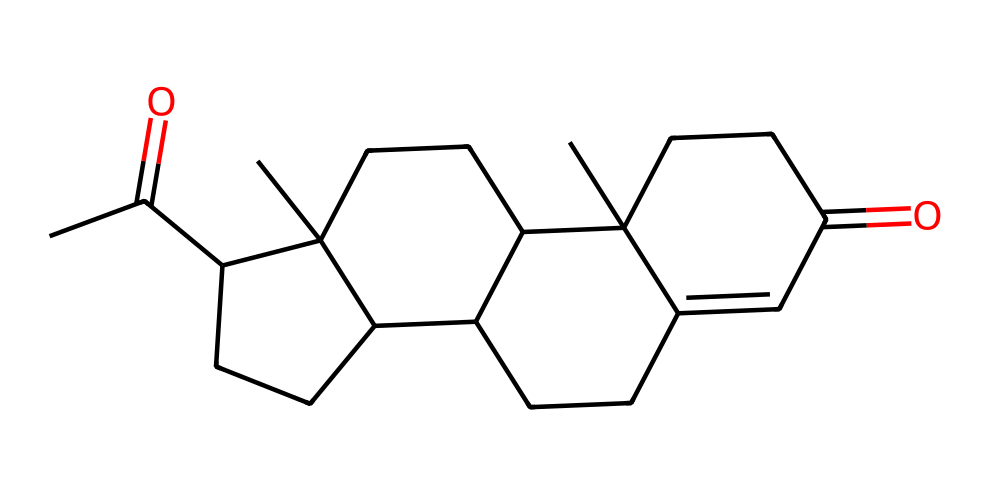What is the molecular formula of the compound represented by this SMILES? To determine the molecular formula from the SMILES representation, we count the atoms of each element present in the structure. The given SMILES contains 21 carbon (C) atoms, 30 hydrogen (H) atoms, and 2 oxygen (O) atoms, leading to the molecular formula C21H30O2.
Answer: C21H30O2 How many rings are present in the structure? Analyzing the SMILES structure, we can identify the cyclic components by looking for numbers that indicate where the rings close. In this case, there are four rings present as indicated by the ring closure numbers (1, 2, 3, and 4).
Answer: 4 What type of chemical compound is this? The compound has a characteristic structure of steroid hormones, as it contains multiple fused rings typical for steroids, specifically indicative of a progestin or progesterone-like compound.
Answer: steroid What functional groups are present in the molecule? By examining the structure, we can identify the functional groups: there is a ketone group (C=O) present in the molecule, which is typical for steroids. The specific positions of the ketone groups can also be identified in the structure.
Answer: ketone Which atom is directly involved in the ketone functional group? In the provided structure, the carbon atom that is double-bonded to an oxygen atom (C=O) represents the functional group of a ketone. This is evident from the interpretation of the SMILES notation.
Answer: carbon What is the significance of the presence of the carbonyl group in this compound? The carbonyl group (C=O) contributes to the chemical reactivity and biological activity of the molecule. In the case of hormones like progesterone, it is crucial for their interaction with hormones' receptors and hence, their function in biological systems.
Answer: chemical reactivity What type of products can this compound be synthesized into? This compound, being a steroid hormone, can be synthesized into various derivatives and other steroid hormones, including androgens and estrogens, which play a variety of roles in biological processes.
Answer: steroid derivatives 